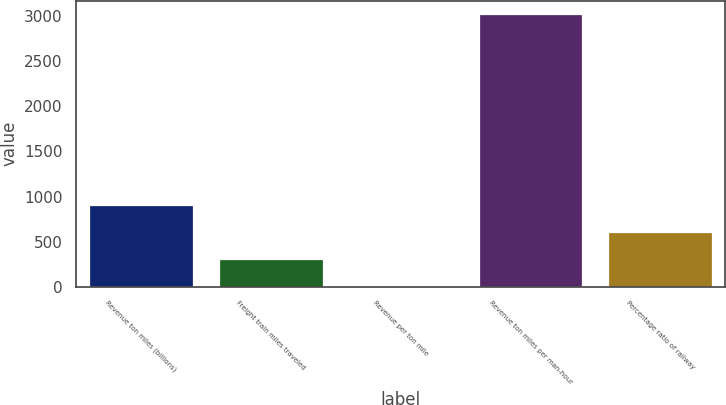Convert chart to OTSL. <chart><loc_0><loc_0><loc_500><loc_500><bar_chart><fcel>Revenue ton miles (billions)<fcel>Freight train miles traveled<fcel>Revenue per ton mile<fcel>Revenue ton miles per man-hour<fcel>Percentage ratio of railway<nl><fcel>906.93<fcel>302.33<fcel>0.03<fcel>3023<fcel>604.63<nl></chart> 